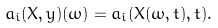<formula> <loc_0><loc_0><loc_500><loc_500>a _ { i } ( X , y ) ( \omega ) = a _ { i } ( X ( \omega , t ) , t ) .</formula> 